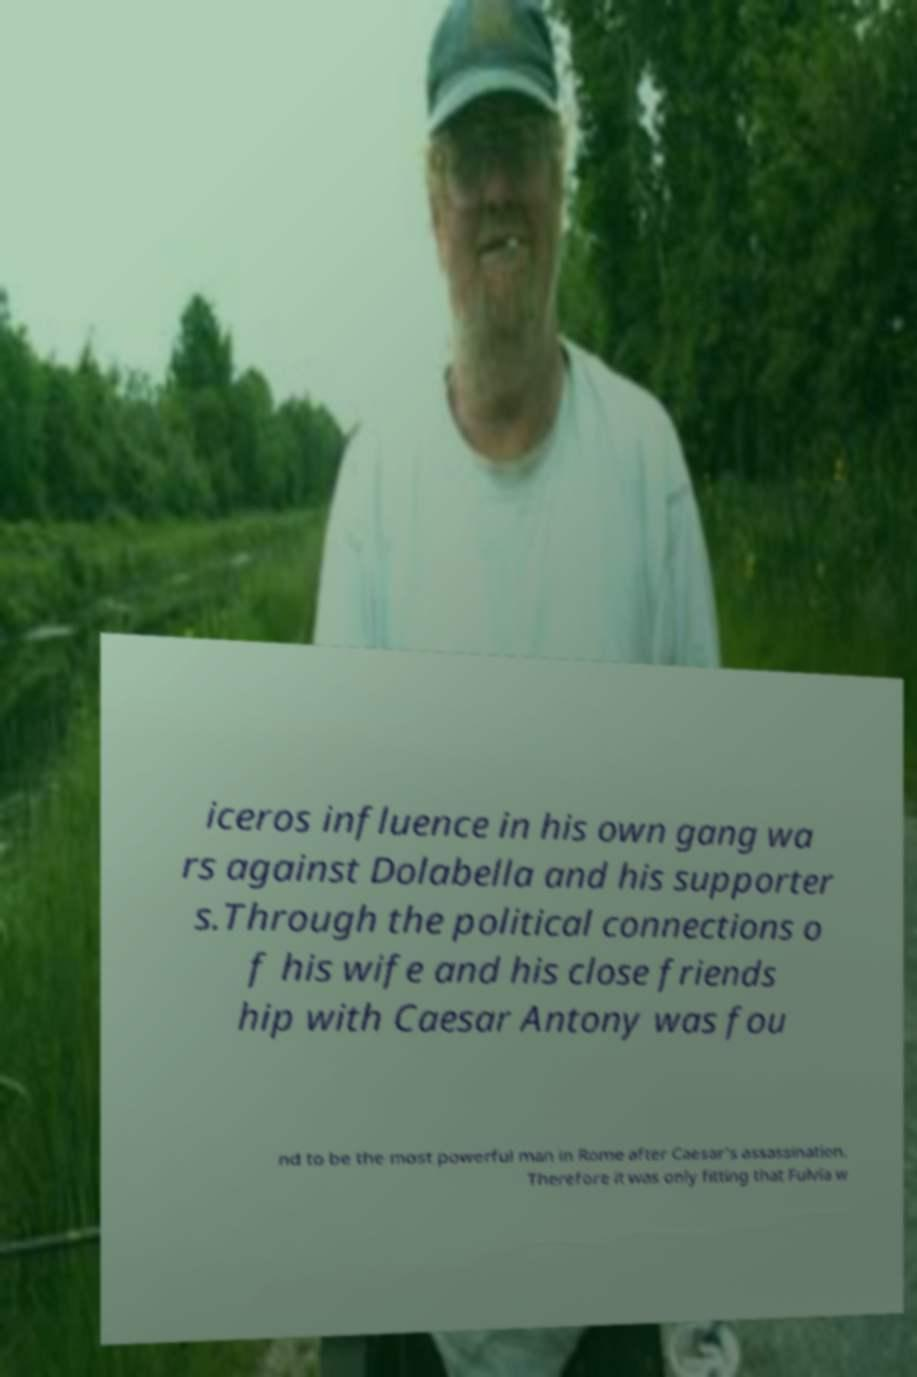Could you assist in decoding the text presented in this image and type it out clearly? iceros influence in his own gang wa rs against Dolabella and his supporter s.Through the political connections o f his wife and his close friends hip with Caesar Antony was fou nd to be the most powerful man in Rome after Caesar's assassination. Therefore it was only fitting that Fulvia w 